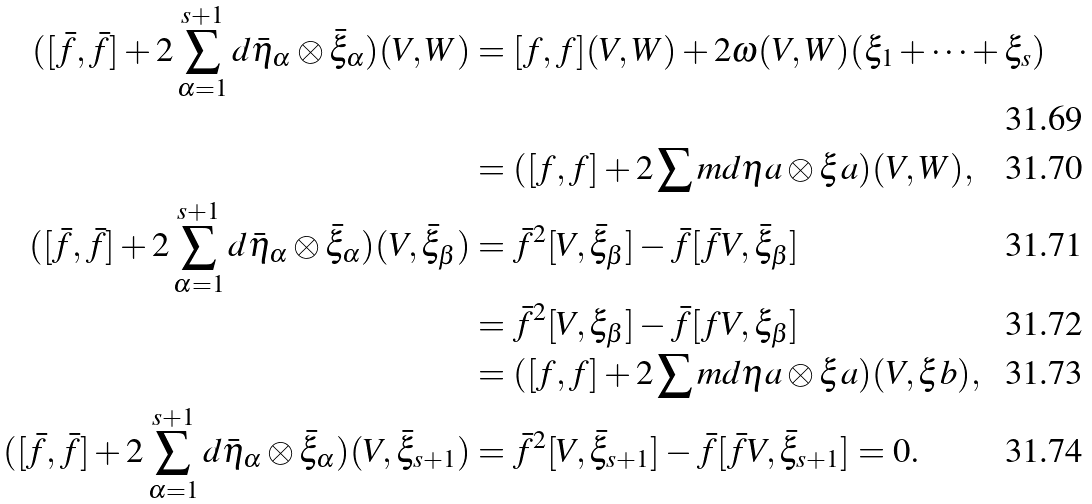<formula> <loc_0><loc_0><loc_500><loc_500>( [ \bar { f } , \bar { f } ] + 2 \sum _ { \alpha = 1 } ^ { s + 1 } d \bar { \eta } _ { \alpha } \otimes \bar { \xi } _ { \alpha } ) ( V , W ) & = [ f , f ] ( V , W ) + 2 \omega ( V , W ) ( { \xi } _ { 1 } + \dots + { \xi } _ { s } ) \\ & = ( [ f , f ] + 2 \sum m d \eta a \otimes \xi a ) ( V , W ) , \\ ( [ \bar { f } , \bar { f } ] + 2 \sum _ { \alpha = 1 } ^ { s + 1 } d \bar { \eta } _ { \alpha } \otimes \bar { \xi } _ { \alpha } ) ( V , \bar { \xi } _ { \beta } ) & = \bar { f } ^ { 2 } [ V , \bar { \xi } _ { \beta } ] - \bar { f } [ \bar { f } V , \bar { \xi } _ { \beta } ] \\ & = \bar { f } ^ { 2 } [ V , { \xi } _ { \beta } ] - \bar { f } [ { f } V , { \xi } _ { \beta } ] \\ & = ( [ f , f ] + 2 \sum m d \eta a \otimes \xi a ) ( V , \xi b ) , \\ ( [ \bar { f } , \bar { f } ] + 2 \sum _ { \alpha = 1 } ^ { s + 1 } d \bar { \eta } _ { \alpha } \otimes \bar { \xi } _ { \alpha } ) ( V , \bar { \xi } _ { s + 1 } ) & = \bar { f } ^ { 2 } [ V , \bar { \xi } _ { s + 1 } ] - \bar { f } [ \bar { f } V , \bar { \xi } _ { s + 1 } ] = 0 .</formula> 